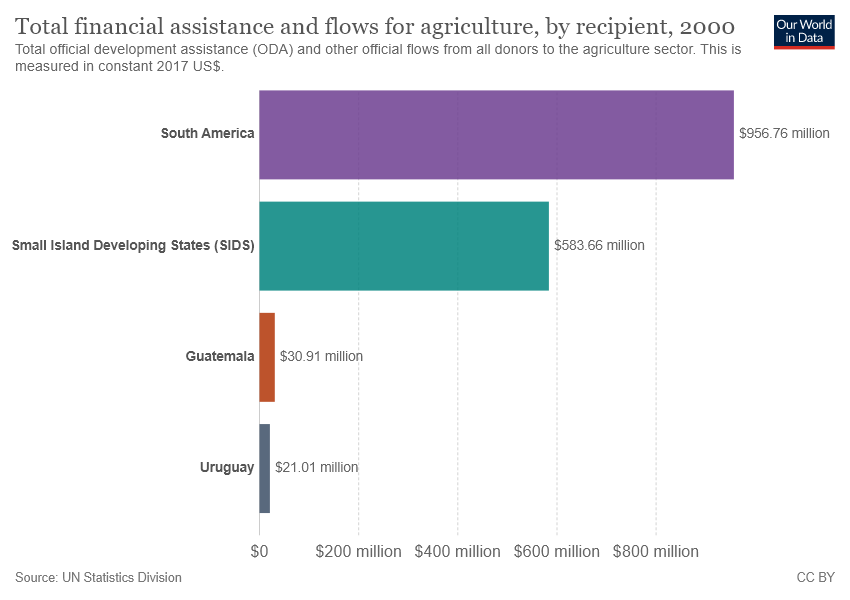Highlight a few significant elements in this photo. Uruguay has the lowest value among the countries. The total value of Uruguay and Guatemala is 51.92. 